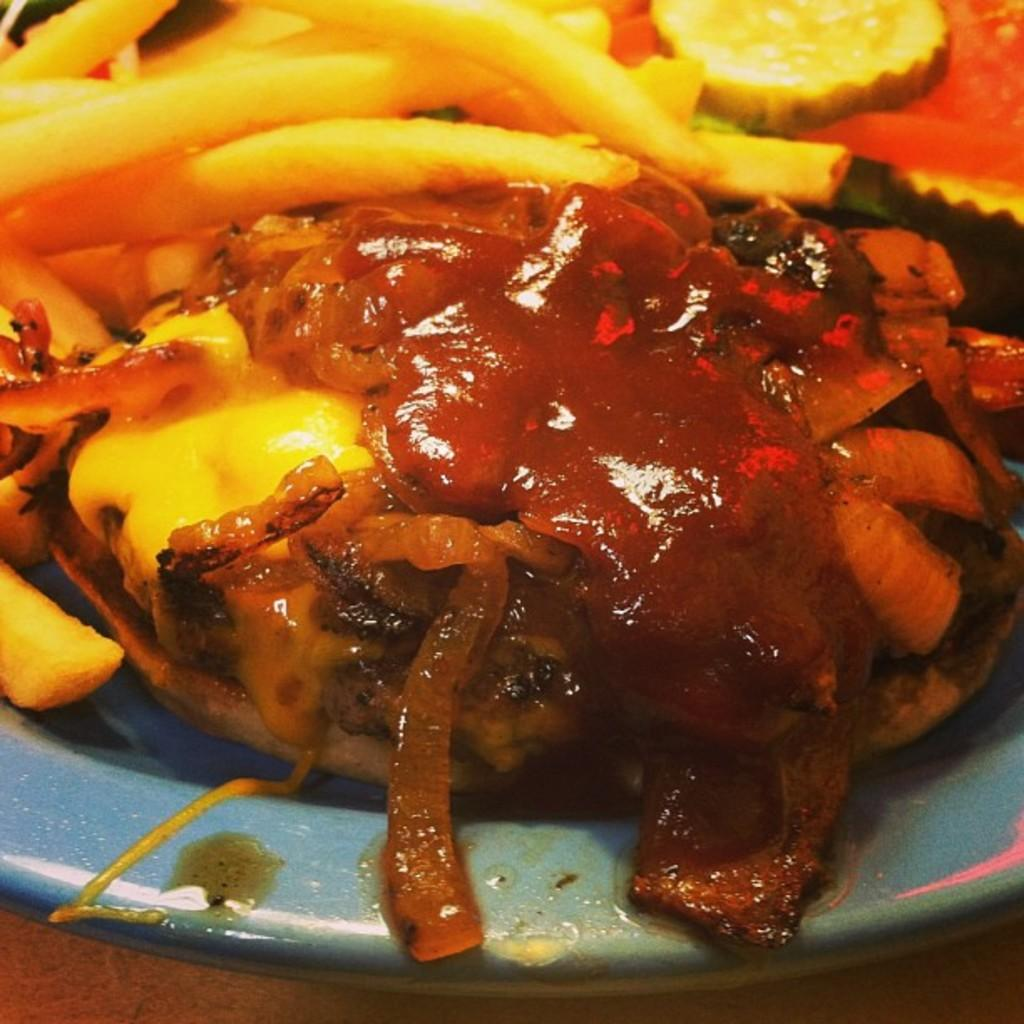What is present on the plate in the image? There is food on the plate in the image. What type of song is being sung by the person wearing a vest at the party in the image? There is no person wearing a vest or party taking place in the image; it only shows a plate of food. 